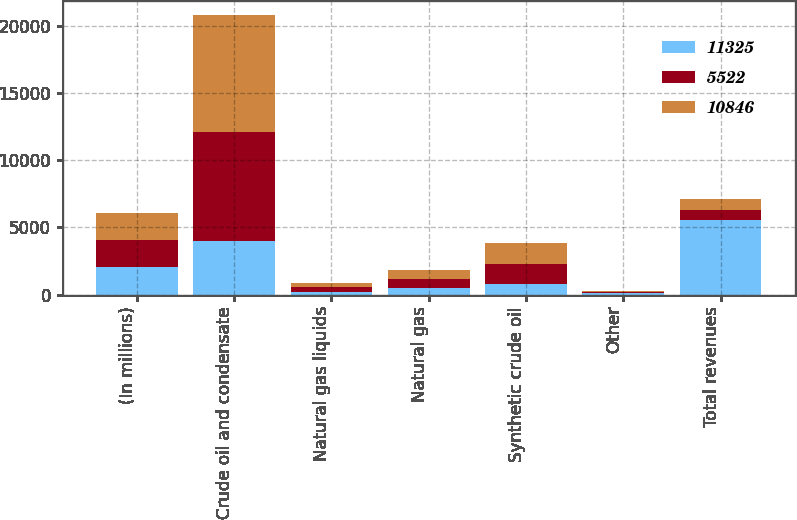Convert chart. <chart><loc_0><loc_0><loc_500><loc_500><stacked_bar_chart><ecel><fcel>(In millions)<fcel>Crude oil and condensate<fcel>Natural gas liquids<fcel>Natural gas<fcel>Synthetic crude oil<fcel>Other<fcel>Total revenues<nl><fcel>11325<fcel>2015<fcel>3963<fcel>203<fcel>464<fcel>781<fcel>111<fcel>5522<nl><fcel>5522<fcel>2014<fcel>8170<fcel>371<fcel>693<fcel>1525<fcel>87<fcel>781<nl><fcel>10846<fcel>2013<fcel>8688<fcel>313<fcel>693<fcel>1542<fcel>89<fcel>781<nl></chart> 